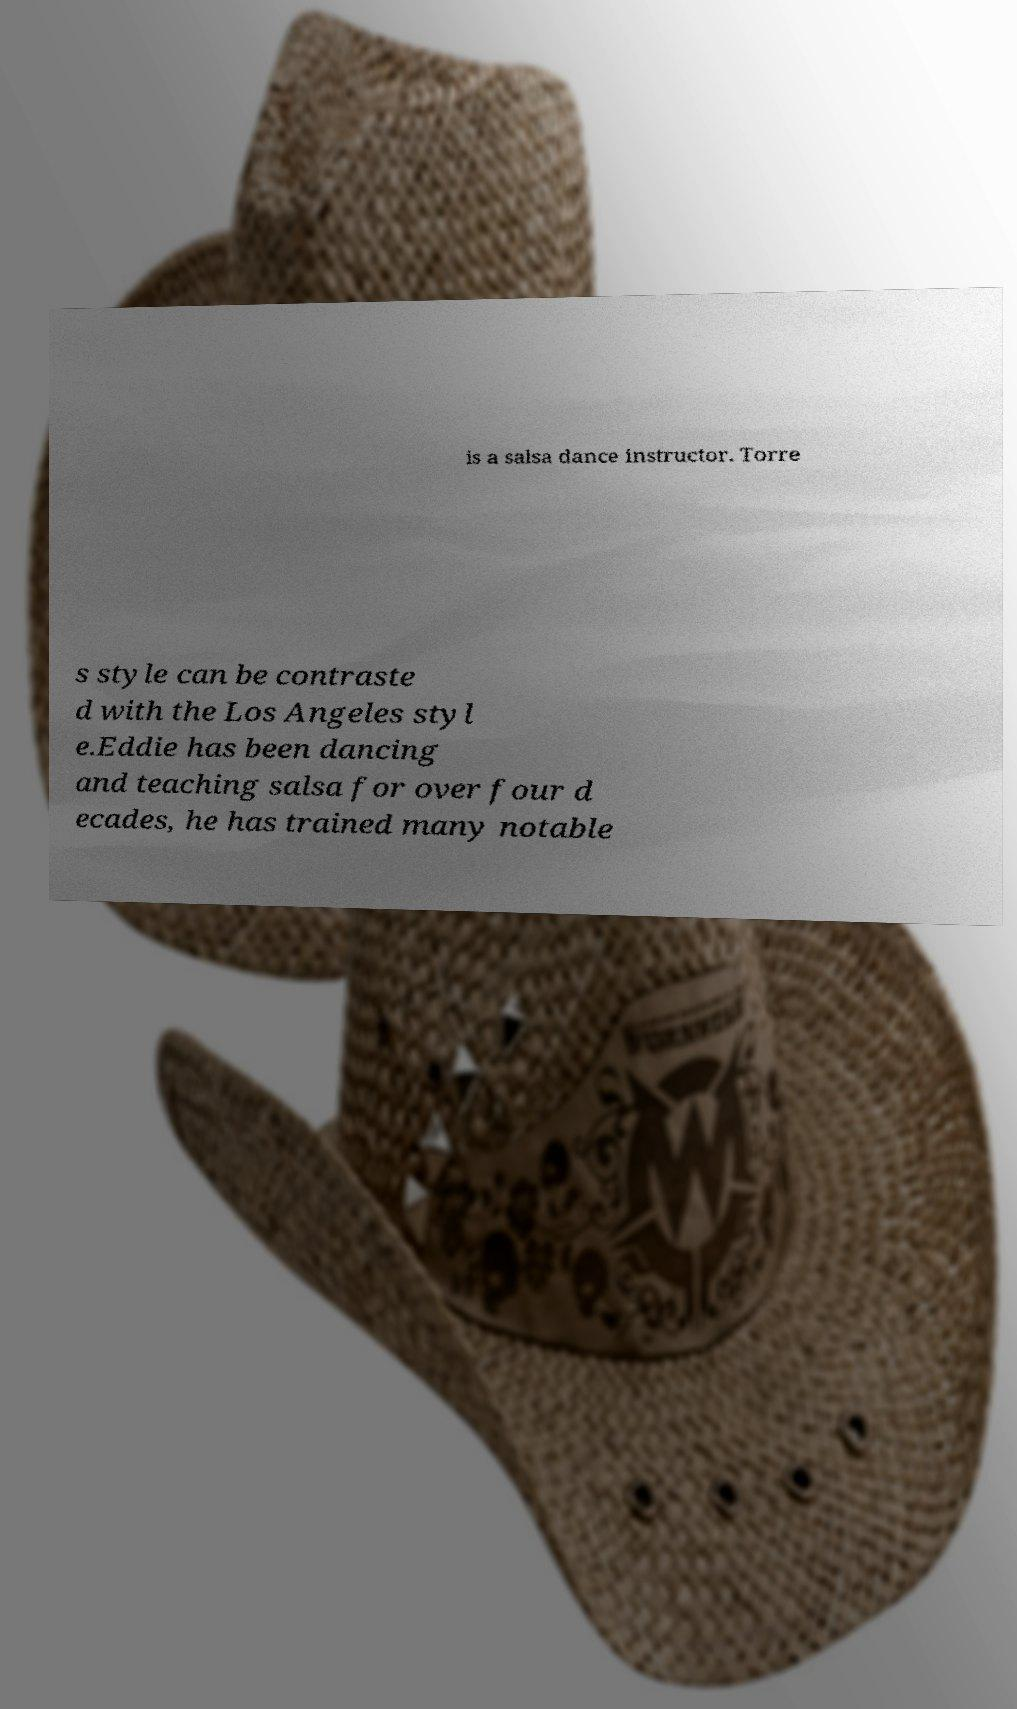Could you extract and type out the text from this image? is a salsa dance instructor. Torre s style can be contraste d with the Los Angeles styl e.Eddie has been dancing and teaching salsa for over four d ecades, he has trained many notable 